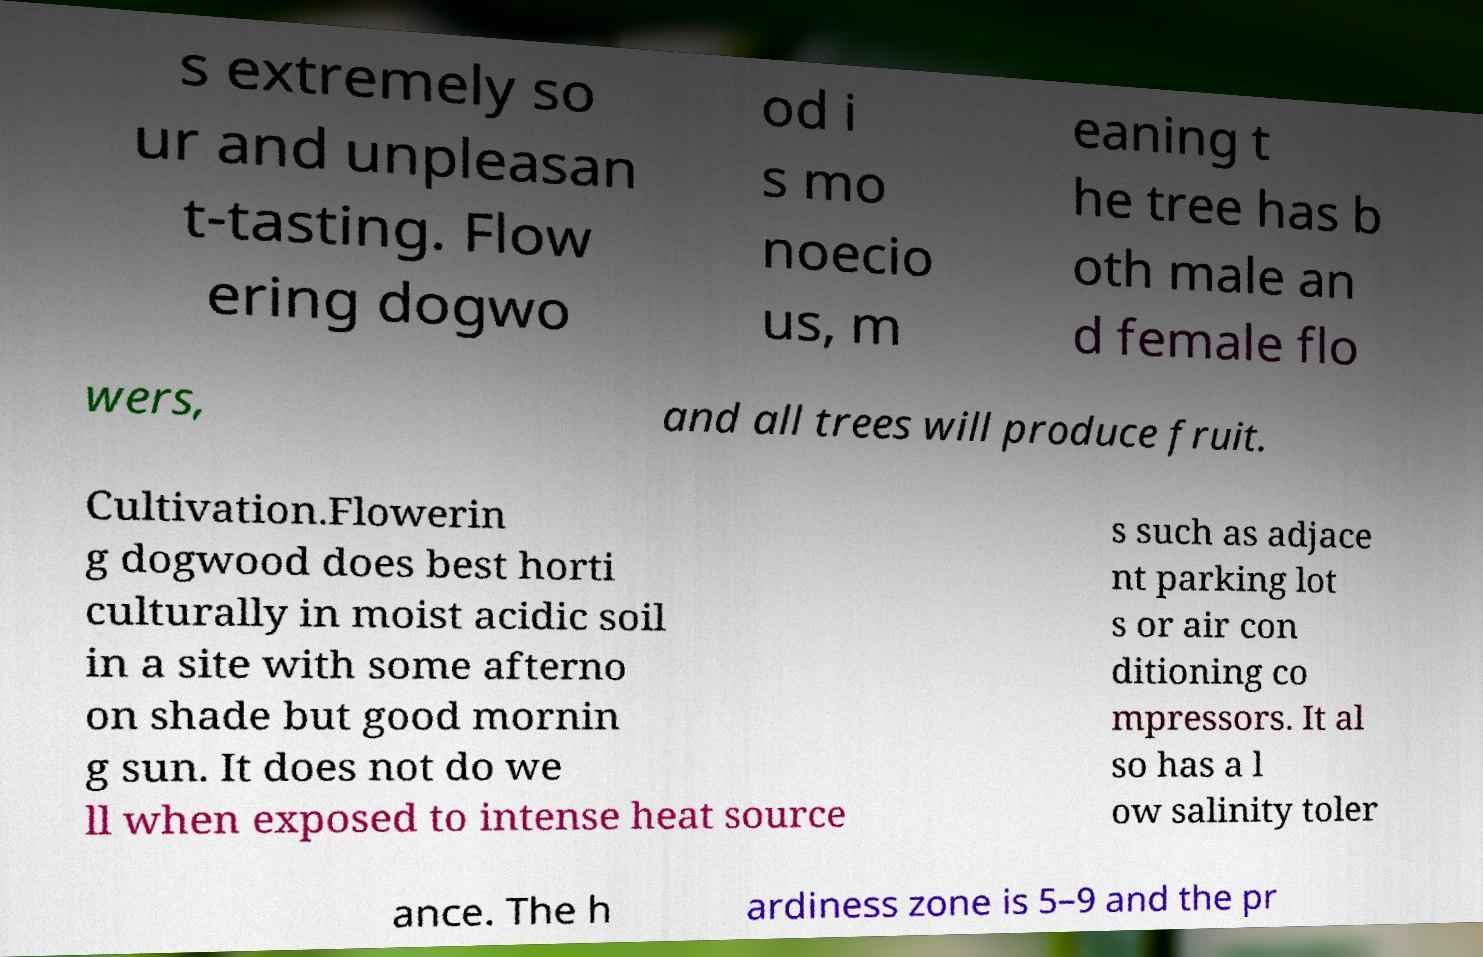Could you extract and type out the text from this image? s extremely so ur and unpleasan t-tasting. Flow ering dogwo od i s mo noecio us, m eaning t he tree has b oth male an d female flo wers, and all trees will produce fruit. Cultivation.Flowerin g dogwood does best horti culturally in moist acidic soil in a site with some afterno on shade but good mornin g sun. It does not do we ll when exposed to intense heat source s such as adjace nt parking lot s or air con ditioning co mpressors. It al so has a l ow salinity toler ance. The h ardiness zone is 5–9 and the pr 